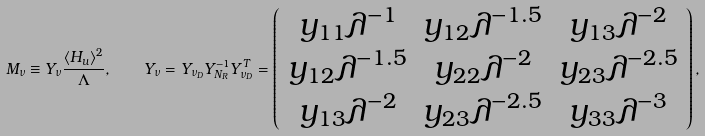<formula> <loc_0><loc_0><loc_500><loc_500>M _ { \nu } \equiv Y _ { \nu } \frac { \langle H _ { u } \rangle ^ { 2 } } { \Lambda } , \quad Y _ { \nu } = Y _ { \nu _ { D } } Y _ { N _ { R } } ^ { - 1 } Y _ { \nu _ { D } } ^ { T } = \left ( \begin{array} { c c c } y _ { 1 1 } \lambda ^ { - 1 } & y _ { 1 2 } \lambda ^ { - 1 . 5 } & y _ { 1 3 } \lambda ^ { - 2 } \\ y _ { 1 2 } \lambda ^ { - 1 . 5 } & y _ { 2 2 } \lambda ^ { - 2 } & y _ { 2 3 } \lambda ^ { - 2 . 5 } \\ y _ { 1 3 } \lambda ^ { - 2 } & y _ { 2 3 } \lambda ^ { - 2 . 5 } & y _ { 3 3 } \lambda ^ { - 3 } \\ \end{array} \right ) ,</formula> 